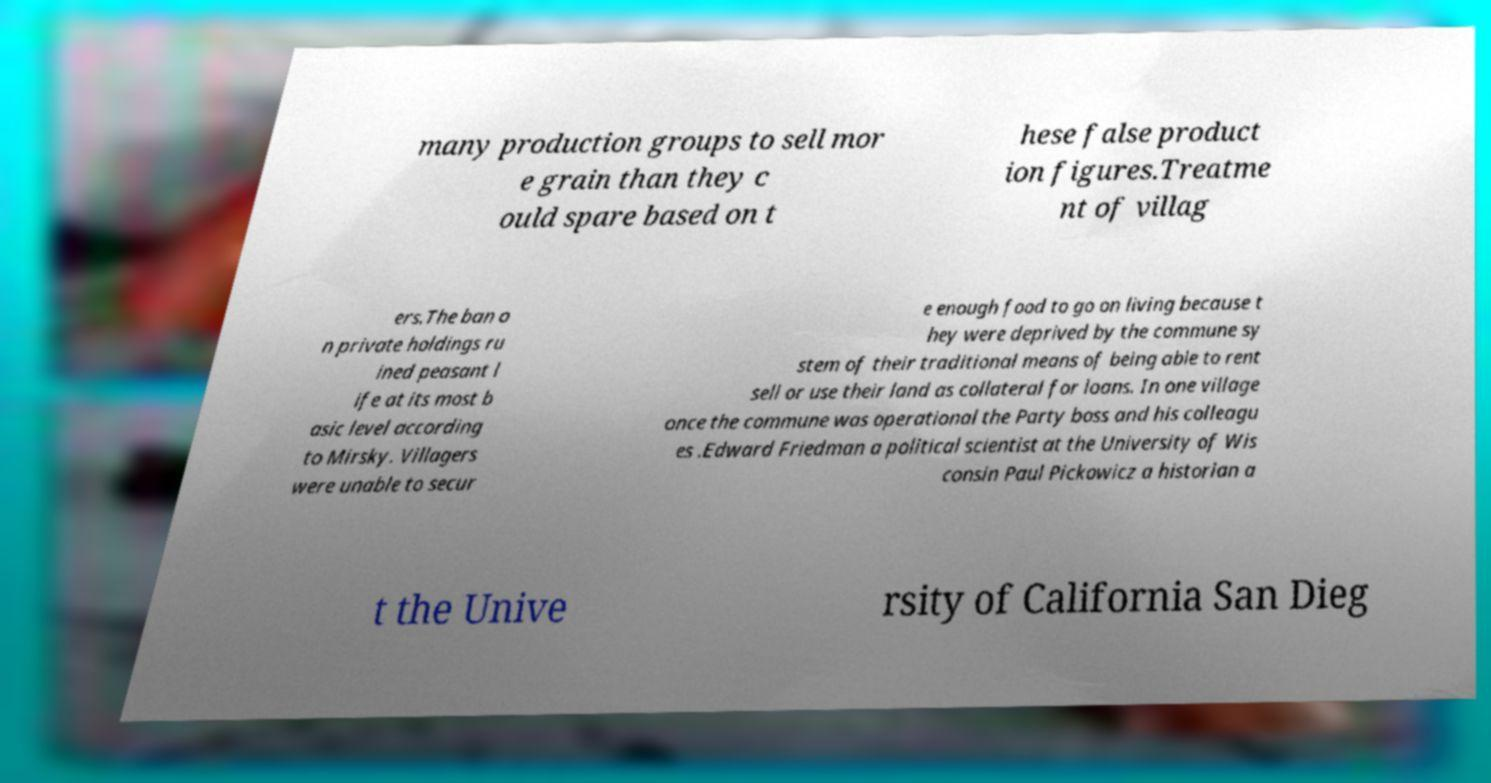Could you assist in decoding the text presented in this image and type it out clearly? many production groups to sell mor e grain than they c ould spare based on t hese false product ion figures.Treatme nt of villag ers.The ban o n private holdings ru ined peasant l ife at its most b asic level according to Mirsky. Villagers were unable to secur e enough food to go on living because t hey were deprived by the commune sy stem of their traditional means of being able to rent sell or use their land as collateral for loans. In one village once the commune was operational the Party boss and his colleagu es .Edward Friedman a political scientist at the University of Wis consin Paul Pickowicz a historian a t the Unive rsity of California San Dieg 